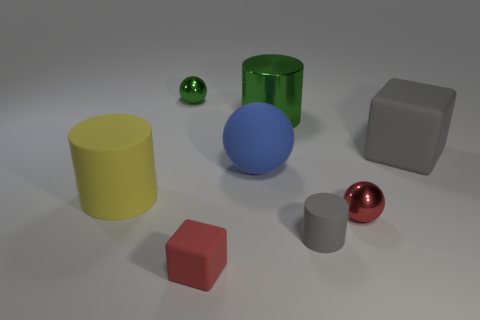There is a gray matte object that is the same size as the shiny cylinder; what is its shape?
Make the answer very short. Cube. Is the color of the large cube the same as the rubber cylinder that is right of the tiny green thing?
Keep it short and to the point. Yes. What number of things are tiny objects that are left of the gray rubber cylinder or green metal objects that are to the right of the red matte thing?
Ensure brevity in your answer.  3. What material is the yellow object that is the same size as the blue matte ball?
Ensure brevity in your answer.  Rubber. How many other things are the same material as the small red block?
Your answer should be compact. 4. There is a green metal thing right of the red matte object; does it have the same shape as the gray object that is on the left side of the large matte block?
Provide a succinct answer. Yes. The small rubber cube on the left side of the small shiny object right of the tiny metal object on the left side of the tiny cube is what color?
Your answer should be compact. Red. How many other things are the same color as the rubber sphere?
Your response must be concise. 0. Are there fewer red cubes than green matte balls?
Offer a very short reply. No. The thing that is left of the large blue object and in front of the large yellow matte cylinder is what color?
Make the answer very short. Red. 